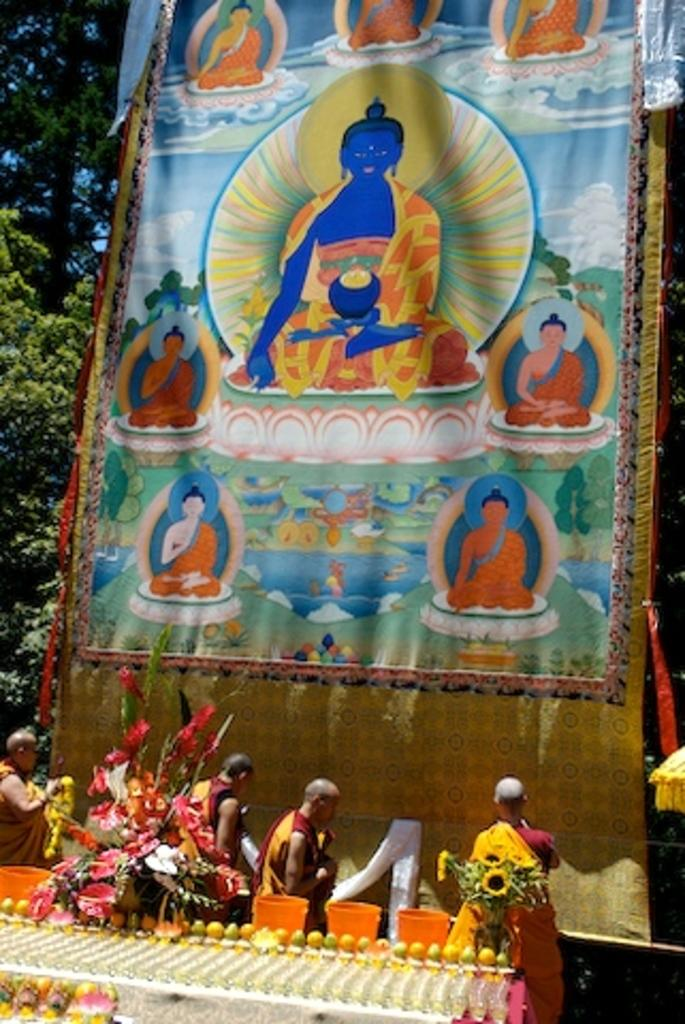What can be seen in the image involving people? There are people standing in the image. What is the purpose of the banner in the image? The purpose of the banner cannot be determined from the image alone. What type of vegetation is present in the image? There are flowers and trees in the image. What is visible in the background of the image? The sky is visible in the image. Can you see any mice running up the hill in the image? There is no hill or mice present in the image. What type of engine is visible in the image? There is no engine present in the image. 